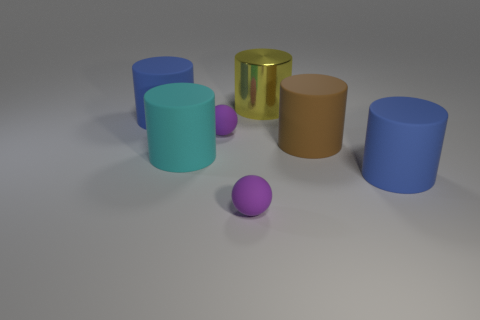Imagine this is a set for teaching shapes and colors. How would you use it? This set would be excellent for a hands-on learning experience. Start by having the students identify each shape—a sphere or cylinder. Then, move on to colors, pointing out each object's hue. You could arrange the items in sequences of colors or sizes, or even use the objects for counting exercises. The variety in shapes and colors can also be used to introduce concepts of comparison, such as bigger versus smaller and same versus different. 